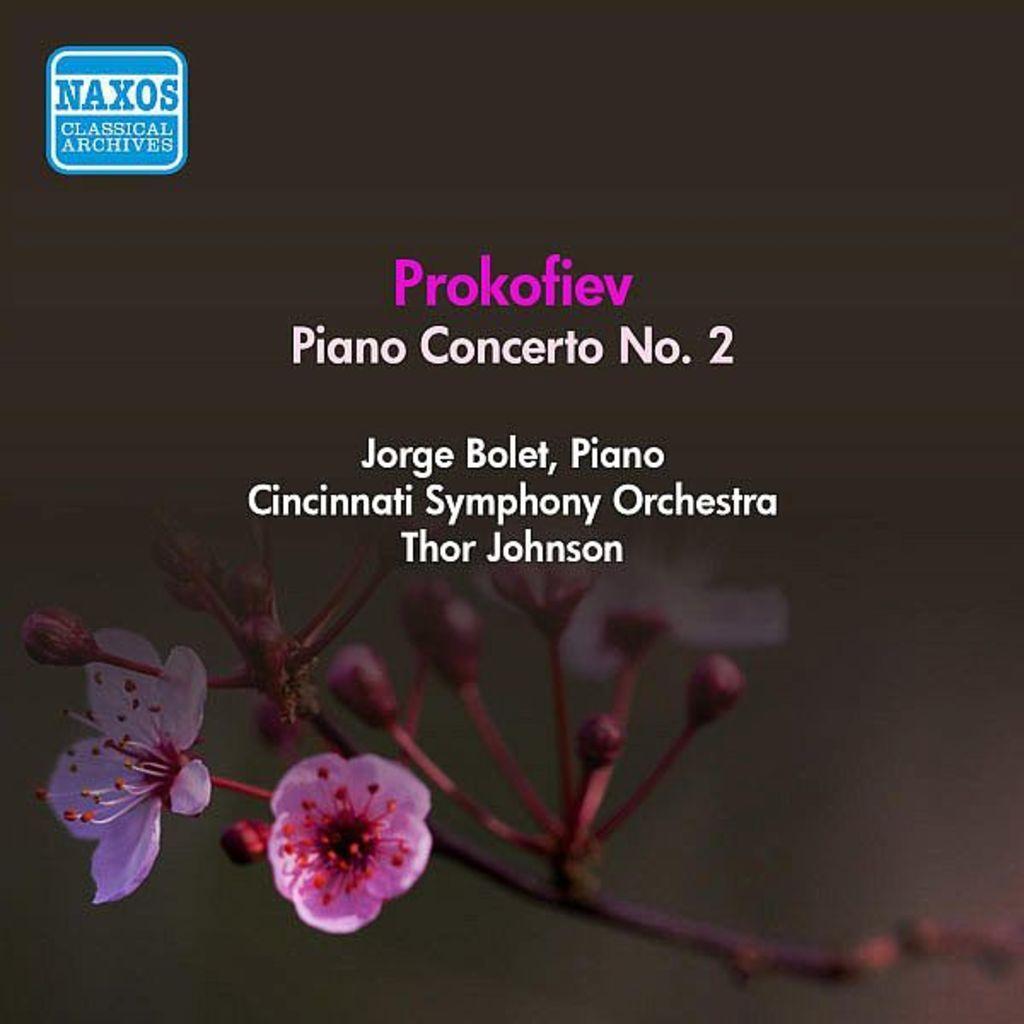Describe this image in one or two sentences. On the top left, there is a watermark. In the middle of this image, there are white and pink color texts. In the background, there is a branch of a tree having flowers. And the background is dark in color. 